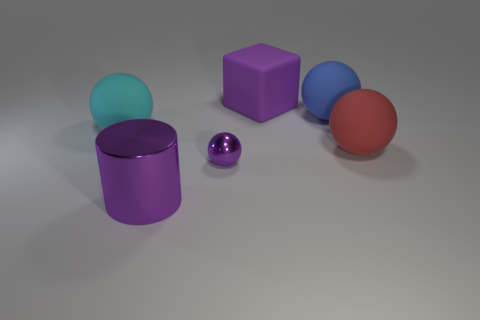What size is the shiny cylinder that is the same color as the tiny metal object?
Give a very brief answer. Large. What number of objects are large rubber cylinders or large purple rubber cubes?
Your answer should be very brief. 1. The large thing that is to the left of the big purple object in front of the red matte object is what shape?
Provide a short and direct response. Sphere. There is a big purple object to the left of the rubber block; is its shape the same as the big cyan matte object?
Offer a terse response. No. The purple object that is the same material as the blue object is what size?
Make the answer very short. Large. What number of things are either objects that are in front of the purple sphere or purple things in front of the small purple ball?
Provide a succinct answer. 1. Is the number of cyan spheres that are right of the cyan matte thing the same as the number of big shiny cylinders behind the purple block?
Provide a succinct answer. Yes. There is a big ball that is left of the big metallic object; what is its color?
Provide a succinct answer. Cyan. Is the color of the tiny object the same as the rubber ball left of the big purple metal object?
Your answer should be compact. No. Is the number of small objects less than the number of big red metal objects?
Offer a very short reply. No. 